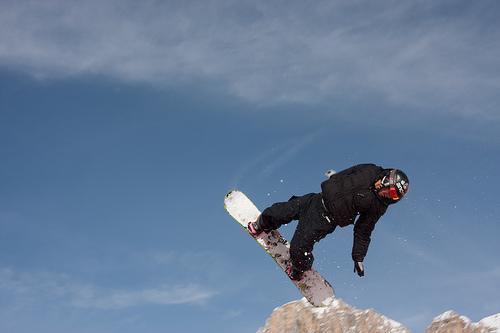How many people are in the photo?
Give a very brief answer. 1. 